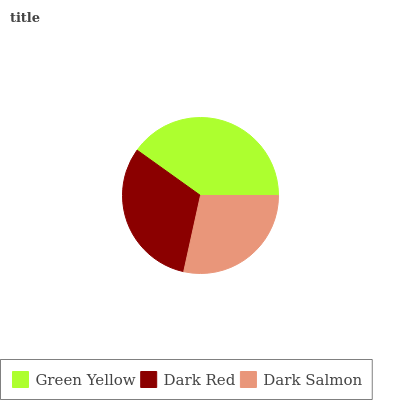Is Dark Salmon the minimum?
Answer yes or no. Yes. Is Green Yellow the maximum?
Answer yes or no. Yes. Is Dark Red the minimum?
Answer yes or no. No. Is Dark Red the maximum?
Answer yes or no. No. Is Green Yellow greater than Dark Red?
Answer yes or no. Yes. Is Dark Red less than Green Yellow?
Answer yes or no. Yes. Is Dark Red greater than Green Yellow?
Answer yes or no. No. Is Green Yellow less than Dark Red?
Answer yes or no. No. Is Dark Red the high median?
Answer yes or no. Yes. Is Dark Red the low median?
Answer yes or no. Yes. Is Dark Salmon the high median?
Answer yes or no. No. Is Green Yellow the low median?
Answer yes or no. No. 